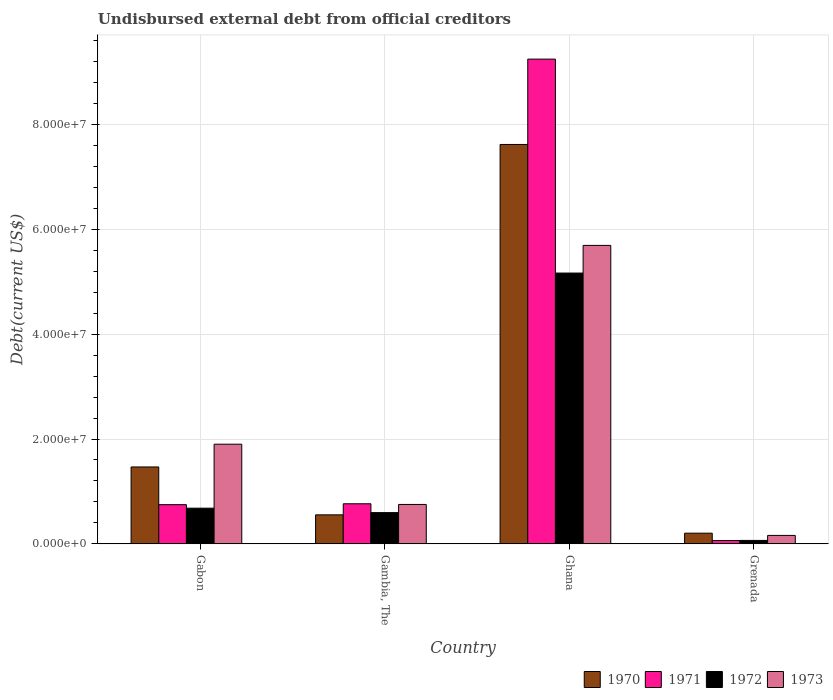How many different coloured bars are there?
Provide a succinct answer. 4. How many groups of bars are there?
Make the answer very short. 4. Are the number of bars per tick equal to the number of legend labels?
Offer a very short reply. Yes. Are the number of bars on each tick of the X-axis equal?
Make the answer very short. Yes. How many bars are there on the 2nd tick from the right?
Your answer should be compact. 4. What is the label of the 1st group of bars from the left?
Your response must be concise. Gabon. What is the total debt in 1972 in Gabon?
Give a very brief answer. 6.81e+06. Across all countries, what is the maximum total debt in 1972?
Give a very brief answer. 5.17e+07. Across all countries, what is the minimum total debt in 1973?
Offer a terse response. 1.61e+06. In which country was the total debt in 1970 maximum?
Provide a succinct answer. Ghana. In which country was the total debt in 1972 minimum?
Give a very brief answer. Grenada. What is the total total debt in 1971 in the graph?
Keep it short and to the point. 1.08e+08. What is the difference between the total debt in 1971 in Gambia, The and that in Ghana?
Provide a succinct answer. -8.48e+07. What is the difference between the total debt in 1972 in Ghana and the total debt in 1971 in Gabon?
Give a very brief answer. 4.42e+07. What is the average total debt in 1972 per country?
Provide a short and direct response. 1.63e+07. What is the difference between the total debt of/in 1973 and total debt of/in 1971 in Gabon?
Keep it short and to the point. 1.15e+07. In how many countries, is the total debt in 1973 greater than 44000000 US$?
Offer a very short reply. 1. What is the ratio of the total debt in 1971 in Gabon to that in Ghana?
Your answer should be very brief. 0.08. What is the difference between the highest and the second highest total debt in 1973?
Your answer should be very brief. 4.94e+07. What is the difference between the highest and the lowest total debt in 1973?
Give a very brief answer. 5.53e+07. Is it the case that in every country, the sum of the total debt in 1972 and total debt in 1973 is greater than the total debt in 1970?
Your answer should be compact. Yes. How many bars are there?
Offer a very short reply. 16. Does the graph contain any zero values?
Keep it short and to the point. No. Does the graph contain grids?
Keep it short and to the point. Yes. Where does the legend appear in the graph?
Give a very brief answer. Bottom right. What is the title of the graph?
Make the answer very short. Undisbursed external debt from official creditors. Does "1987" appear as one of the legend labels in the graph?
Your answer should be very brief. No. What is the label or title of the Y-axis?
Ensure brevity in your answer.  Debt(current US$). What is the Debt(current US$) in 1970 in Gabon?
Offer a very short reply. 1.47e+07. What is the Debt(current US$) in 1971 in Gabon?
Your answer should be very brief. 7.48e+06. What is the Debt(current US$) in 1972 in Gabon?
Make the answer very short. 6.81e+06. What is the Debt(current US$) in 1973 in Gabon?
Keep it short and to the point. 1.90e+07. What is the Debt(current US$) in 1970 in Gambia, The?
Your answer should be very brief. 5.54e+06. What is the Debt(current US$) in 1971 in Gambia, The?
Give a very brief answer. 7.65e+06. What is the Debt(current US$) of 1972 in Gambia, The?
Ensure brevity in your answer.  5.96e+06. What is the Debt(current US$) of 1973 in Gambia, The?
Make the answer very short. 7.52e+06. What is the Debt(current US$) in 1970 in Ghana?
Your answer should be very brief. 7.62e+07. What is the Debt(current US$) in 1971 in Ghana?
Your response must be concise. 9.25e+07. What is the Debt(current US$) of 1972 in Ghana?
Offer a terse response. 5.17e+07. What is the Debt(current US$) in 1973 in Ghana?
Your answer should be compact. 5.69e+07. What is the Debt(current US$) in 1970 in Grenada?
Offer a very short reply. 2.04e+06. What is the Debt(current US$) of 1971 in Grenada?
Ensure brevity in your answer.  6.39e+05. What is the Debt(current US$) of 1972 in Grenada?
Your answer should be compact. 6.57e+05. What is the Debt(current US$) of 1973 in Grenada?
Your response must be concise. 1.61e+06. Across all countries, what is the maximum Debt(current US$) in 1970?
Make the answer very short. 7.62e+07. Across all countries, what is the maximum Debt(current US$) in 1971?
Your answer should be compact. 9.25e+07. Across all countries, what is the maximum Debt(current US$) of 1972?
Your answer should be very brief. 5.17e+07. Across all countries, what is the maximum Debt(current US$) of 1973?
Make the answer very short. 5.69e+07. Across all countries, what is the minimum Debt(current US$) of 1970?
Give a very brief answer. 2.04e+06. Across all countries, what is the minimum Debt(current US$) in 1971?
Make the answer very short. 6.39e+05. Across all countries, what is the minimum Debt(current US$) in 1972?
Ensure brevity in your answer.  6.57e+05. Across all countries, what is the minimum Debt(current US$) of 1973?
Keep it short and to the point. 1.61e+06. What is the total Debt(current US$) in 1970 in the graph?
Your answer should be very brief. 9.84e+07. What is the total Debt(current US$) of 1971 in the graph?
Your response must be concise. 1.08e+08. What is the total Debt(current US$) in 1972 in the graph?
Offer a very short reply. 6.51e+07. What is the total Debt(current US$) of 1973 in the graph?
Offer a terse response. 8.51e+07. What is the difference between the Debt(current US$) in 1970 in Gabon and that in Gambia, The?
Offer a terse response. 9.14e+06. What is the difference between the Debt(current US$) in 1971 in Gabon and that in Gambia, The?
Make the answer very short. -1.71e+05. What is the difference between the Debt(current US$) in 1972 in Gabon and that in Gambia, The?
Make the answer very short. 8.46e+05. What is the difference between the Debt(current US$) in 1973 in Gabon and that in Gambia, The?
Your answer should be very brief. 1.15e+07. What is the difference between the Debt(current US$) in 1970 in Gabon and that in Ghana?
Provide a succinct answer. -6.15e+07. What is the difference between the Debt(current US$) in 1971 in Gabon and that in Ghana?
Provide a succinct answer. -8.50e+07. What is the difference between the Debt(current US$) in 1972 in Gabon and that in Ghana?
Offer a terse response. -4.49e+07. What is the difference between the Debt(current US$) in 1973 in Gabon and that in Ghana?
Offer a terse response. -3.79e+07. What is the difference between the Debt(current US$) in 1970 in Gabon and that in Grenada?
Offer a very short reply. 1.26e+07. What is the difference between the Debt(current US$) of 1971 in Gabon and that in Grenada?
Ensure brevity in your answer.  6.84e+06. What is the difference between the Debt(current US$) of 1972 in Gabon and that in Grenada?
Keep it short and to the point. 6.15e+06. What is the difference between the Debt(current US$) of 1973 in Gabon and that in Grenada?
Offer a terse response. 1.74e+07. What is the difference between the Debt(current US$) in 1970 in Gambia, The and that in Ghana?
Ensure brevity in your answer.  -7.07e+07. What is the difference between the Debt(current US$) in 1971 in Gambia, The and that in Ghana?
Your answer should be compact. -8.48e+07. What is the difference between the Debt(current US$) of 1972 in Gambia, The and that in Ghana?
Your response must be concise. -4.57e+07. What is the difference between the Debt(current US$) of 1973 in Gambia, The and that in Ghana?
Your response must be concise. -4.94e+07. What is the difference between the Debt(current US$) in 1970 in Gambia, The and that in Grenada?
Give a very brief answer. 3.50e+06. What is the difference between the Debt(current US$) of 1971 in Gambia, The and that in Grenada?
Offer a terse response. 7.01e+06. What is the difference between the Debt(current US$) of 1972 in Gambia, The and that in Grenada?
Give a very brief answer. 5.30e+06. What is the difference between the Debt(current US$) of 1973 in Gambia, The and that in Grenada?
Ensure brevity in your answer.  5.91e+06. What is the difference between the Debt(current US$) in 1970 in Ghana and that in Grenada?
Your response must be concise. 7.42e+07. What is the difference between the Debt(current US$) in 1971 in Ghana and that in Grenada?
Keep it short and to the point. 9.18e+07. What is the difference between the Debt(current US$) in 1972 in Ghana and that in Grenada?
Your response must be concise. 5.10e+07. What is the difference between the Debt(current US$) in 1973 in Ghana and that in Grenada?
Offer a terse response. 5.53e+07. What is the difference between the Debt(current US$) in 1970 in Gabon and the Debt(current US$) in 1971 in Gambia, The?
Make the answer very short. 7.02e+06. What is the difference between the Debt(current US$) of 1970 in Gabon and the Debt(current US$) of 1972 in Gambia, The?
Give a very brief answer. 8.71e+06. What is the difference between the Debt(current US$) in 1970 in Gabon and the Debt(current US$) in 1973 in Gambia, The?
Offer a terse response. 7.15e+06. What is the difference between the Debt(current US$) in 1971 in Gabon and the Debt(current US$) in 1972 in Gambia, The?
Your answer should be very brief. 1.52e+06. What is the difference between the Debt(current US$) in 1971 in Gabon and the Debt(current US$) in 1973 in Gambia, The?
Offer a very short reply. -4.10e+04. What is the difference between the Debt(current US$) in 1972 in Gabon and the Debt(current US$) in 1973 in Gambia, The?
Offer a very short reply. -7.11e+05. What is the difference between the Debt(current US$) of 1970 in Gabon and the Debt(current US$) of 1971 in Ghana?
Make the answer very short. -7.78e+07. What is the difference between the Debt(current US$) of 1970 in Gabon and the Debt(current US$) of 1972 in Ghana?
Offer a terse response. -3.70e+07. What is the difference between the Debt(current US$) in 1970 in Gabon and the Debt(current US$) in 1973 in Ghana?
Give a very brief answer. -4.23e+07. What is the difference between the Debt(current US$) of 1971 in Gabon and the Debt(current US$) of 1972 in Ghana?
Your response must be concise. -4.42e+07. What is the difference between the Debt(current US$) of 1971 in Gabon and the Debt(current US$) of 1973 in Ghana?
Your answer should be compact. -4.95e+07. What is the difference between the Debt(current US$) in 1972 in Gabon and the Debt(current US$) in 1973 in Ghana?
Provide a succinct answer. -5.01e+07. What is the difference between the Debt(current US$) in 1970 in Gabon and the Debt(current US$) in 1971 in Grenada?
Ensure brevity in your answer.  1.40e+07. What is the difference between the Debt(current US$) in 1970 in Gabon and the Debt(current US$) in 1972 in Grenada?
Your answer should be very brief. 1.40e+07. What is the difference between the Debt(current US$) of 1970 in Gabon and the Debt(current US$) of 1973 in Grenada?
Give a very brief answer. 1.31e+07. What is the difference between the Debt(current US$) of 1971 in Gabon and the Debt(current US$) of 1972 in Grenada?
Keep it short and to the point. 6.82e+06. What is the difference between the Debt(current US$) of 1971 in Gabon and the Debt(current US$) of 1973 in Grenada?
Your response must be concise. 5.87e+06. What is the difference between the Debt(current US$) in 1972 in Gabon and the Debt(current US$) in 1973 in Grenada?
Make the answer very short. 5.20e+06. What is the difference between the Debt(current US$) of 1970 in Gambia, The and the Debt(current US$) of 1971 in Ghana?
Make the answer very short. -8.69e+07. What is the difference between the Debt(current US$) of 1970 in Gambia, The and the Debt(current US$) of 1972 in Ghana?
Provide a short and direct response. -4.61e+07. What is the difference between the Debt(current US$) of 1970 in Gambia, The and the Debt(current US$) of 1973 in Ghana?
Offer a very short reply. -5.14e+07. What is the difference between the Debt(current US$) in 1971 in Gambia, The and the Debt(current US$) in 1972 in Ghana?
Keep it short and to the point. -4.40e+07. What is the difference between the Debt(current US$) in 1971 in Gambia, The and the Debt(current US$) in 1973 in Ghana?
Offer a very short reply. -4.93e+07. What is the difference between the Debt(current US$) of 1972 in Gambia, The and the Debt(current US$) of 1973 in Ghana?
Offer a terse response. -5.10e+07. What is the difference between the Debt(current US$) of 1970 in Gambia, The and the Debt(current US$) of 1971 in Grenada?
Provide a succinct answer. 4.90e+06. What is the difference between the Debt(current US$) in 1970 in Gambia, The and the Debt(current US$) in 1972 in Grenada?
Your answer should be very brief. 4.88e+06. What is the difference between the Debt(current US$) in 1970 in Gambia, The and the Debt(current US$) in 1973 in Grenada?
Provide a succinct answer. 3.92e+06. What is the difference between the Debt(current US$) in 1971 in Gambia, The and the Debt(current US$) in 1972 in Grenada?
Offer a terse response. 6.99e+06. What is the difference between the Debt(current US$) in 1971 in Gambia, The and the Debt(current US$) in 1973 in Grenada?
Make the answer very short. 6.04e+06. What is the difference between the Debt(current US$) of 1972 in Gambia, The and the Debt(current US$) of 1973 in Grenada?
Provide a succinct answer. 4.35e+06. What is the difference between the Debt(current US$) in 1970 in Ghana and the Debt(current US$) in 1971 in Grenada?
Provide a short and direct response. 7.56e+07. What is the difference between the Debt(current US$) of 1970 in Ghana and the Debt(current US$) of 1972 in Grenada?
Give a very brief answer. 7.55e+07. What is the difference between the Debt(current US$) in 1970 in Ghana and the Debt(current US$) in 1973 in Grenada?
Keep it short and to the point. 7.46e+07. What is the difference between the Debt(current US$) in 1971 in Ghana and the Debt(current US$) in 1972 in Grenada?
Offer a terse response. 9.18e+07. What is the difference between the Debt(current US$) in 1971 in Ghana and the Debt(current US$) in 1973 in Grenada?
Keep it short and to the point. 9.09e+07. What is the difference between the Debt(current US$) of 1972 in Ghana and the Debt(current US$) of 1973 in Grenada?
Give a very brief answer. 5.00e+07. What is the average Debt(current US$) of 1970 per country?
Keep it short and to the point. 2.46e+07. What is the average Debt(current US$) in 1971 per country?
Offer a terse response. 2.71e+07. What is the average Debt(current US$) in 1972 per country?
Give a very brief answer. 1.63e+07. What is the average Debt(current US$) in 1973 per country?
Offer a terse response. 2.13e+07. What is the difference between the Debt(current US$) of 1970 and Debt(current US$) of 1971 in Gabon?
Make the answer very short. 7.19e+06. What is the difference between the Debt(current US$) in 1970 and Debt(current US$) in 1972 in Gabon?
Provide a short and direct response. 7.86e+06. What is the difference between the Debt(current US$) in 1970 and Debt(current US$) in 1973 in Gabon?
Offer a terse response. -4.34e+06. What is the difference between the Debt(current US$) in 1971 and Debt(current US$) in 1972 in Gabon?
Give a very brief answer. 6.70e+05. What is the difference between the Debt(current US$) in 1971 and Debt(current US$) in 1973 in Gabon?
Your response must be concise. -1.15e+07. What is the difference between the Debt(current US$) in 1972 and Debt(current US$) in 1973 in Gabon?
Provide a short and direct response. -1.22e+07. What is the difference between the Debt(current US$) of 1970 and Debt(current US$) of 1971 in Gambia, The?
Provide a short and direct response. -2.11e+06. What is the difference between the Debt(current US$) of 1970 and Debt(current US$) of 1972 in Gambia, The?
Provide a succinct answer. -4.26e+05. What is the difference between the Debt(current US$) in 1970 and Debt(current US$) in 1973 in Gambia, The?
Your answer should be compact. -1.98e+06. What is the difference between the Debt(current US$) of 1971 and Debt(current US$) of 1972 in Gambia, The?
Make the answer very short. 1.69e+06. What is the difference between the Debt(current US$) in 1972 and Debt(current US$) in 1973 in Gambia, The?
Your response must be concise. -1.56e+06. What is the difference between the Debt(current US$) of 1970 and Debt(current US$) of 1971 in Ghana?
Give a very brief answer. -1.63e+07. What is the difference between the Debt(current US$) of 1970 and Debt(current US$) of 1972 in Ghana?
Your answer should be very brief. 2.45e+07. What is the difference between the Debt(current US$) in 1970 and Debt(current US$) in 1973 in Ghana?
Give a very brief answer. 1.93e+07. What is the difference between the Debt(current US$) in 1971 and Debt(current US$) in 1972 in Ghana?
Give a very brief answer. 4.08e+07. What is the difference between the Debt(current US$) in 1971 and Debt(current US$) in 1973 in Ghana?
Ensure brevity in your answer.  3.55e+07. What is the difference between the Debt(current US$) in 1972 and Debt(current US$) in 1973 in Ghana?
Make the answer very short. -5.28e+06. What is the difference between the Debt(current US$) of 1970 and Debt(current US$) of 1971 in Grenada?
Make the answer very short. 1.40e+06. What is the difference between the Debt(current US$) of 1970 and Debt(current US$) of 1972 in Grenada?
Your response must be concise. 1.38e+06. What is the difference between the Debt(current US$) of 1970 and Debt(current US$) of 1973 in Grenada?
Offer a terse response. 4.26e+05. What is the difference between the Debt(current US$) in 1971 and Debt(current US$) in 1972 in Grenada?
Your answer should be compact. -1.80e+04. What is the difference between the Debt(current US$) in 1971 and Debt(current US$) in 1973 in Grenada?
Your answer should be very brief. -9.72e+05. What is the difference between the Debt(current US$) in 1972 and Debt(current US$) in 1973 in Grenada?
Your response must be concise. -9.54e+05. What is the ratio of the Debt(current US$) of 1970 in Gabon to that in Gambia, The?
Provide a short and direct response. 2.65. What is the ratio of the Debt(current US$) in 1971 in Gabon to that in Gambia, The?
Keep it short and to the point. 0.98. What is the ratio of the Debt(current US$) in 1972 in Gabon to that in Gambia, The?
Ensure brevity in your answer.  1.14. What is the ratio of the Debt(current US$) of 1973 in Gabon to that in Gambia, The?
Make the answer very short. 2.53. What is the ratio of the Debt(current US$) of 1970 in Gabon to that in Ghana?
Give a very brief answer. 0.19. What is the ratio of the Debt(current US$) in 1971 in Gabon to that in Ghana?
Give a very brief answer. 0.08. What is the ratio of the Debt(current US$) of 1972 in Gabon to that in Ghana?
Provide a succinct answer. 0.13. What is the ratio of the Debt(current US$) in 1973 in Gabon to that in Ghana?
Your answer should be compact. 0.33. What is the ratio of the Debt(current US$) in 1970 in Gabon to that in Grenada?
Your answer should be very brief. 7.2. What is the ratio of the Debt(current US$) of 1971 in Gabon to that in Grenada?
Your answer should be compact. 11.7. What is the ratio of the Debt(current US$) in 1972 in Gabon to that in Grenada?
Offer a terse response. 10.36. What is the ratio of the Debt(current US$) of 1973 in Gabon to that in Grenada?
Offer a very short reply. 11.8. What is the ratio of the Debt(current US$) in 1970 in Gambia, The to that in Ghana?
Offer a very short reply. 0.07. What is the ratio of the Debt(current US$) of 1971 in Gambia, The to that in Ghana?
Provide a short and direct response. 0.08. What is the ratio of the Debt(current US$) in 1972 in Gambia, The to that in Ghana?
Your answer should be very brief. 0.12. What is the ratio of the Debt(current US$) of 1973 in Gambia, The to that in Ghana?
Provide a short and direct response. 0.13. What is the ratio of the Debt(current US$) of 1970 in Gambia, The to that in Grenada?
Ensure brevity in your answer.  2.72. What is the ratio of the Debt(current US$) of 1971 in Gambia, The to that in Grenada?
Provide a short and direct response. 11.97. What is the ratio of the Debt(current US$) of 1972 in Gambia, The to that in Grenada?
Your response must be concise. 9.07. What is the ratio of the Debt(current US$) in 1973 in Gambia, The to that in Grenada?
Offer a very short reply. 4.67. What is the ratio of the Debt(current US$) of 1970 in Ghana to that in Grenada?
Make the answer very short. 37.4. What is the ratio of the Debt(current US$) of 1971 in Ghana to that in Grenada?
Offer a very short reply. 144.71. What is the ratio of the Debt(current US$) in 1972 in Ghana to that in Grenada?
Make the answer very short. 78.63. What is the ratio of the Debt(current US$) of 1973 in Ghana to that in Grenada?
Make the answer very short. 35.34. What is the difference between the highest and the second highest Debt(current US$) of 1970?
Give a very brief answer. 6.15e+07. What is the difference between the highest and the second highest Debt(current US$) in 1971?
Your answer should be very brief. 8.48e+07. What is the difference between the highest and the second highest Debt(current US$) of 1972?
Provide a short and direct response. 4.49e+07. What is the difference between the highest and the second highest Debt(current US$) in 1973?
Keep it short and to the point. 3.79e+07. What is the difference between the highest and the lowest Debt(current US$) of 1970?
Your answer should be very brief. 7.42e+07. What is the difference between the highest and the lowest Debt(current US$) in 1971?
Give a very brief answer. 9.18e+07. What is the difference between the highest and the lowest Debt(current US$) in 1972?
Make the answer very short. 5.10e+07. What is the difference between the highest and the lowest Debt(current US$) in 1973?
Offer a very short reply. 5.53e+07. 